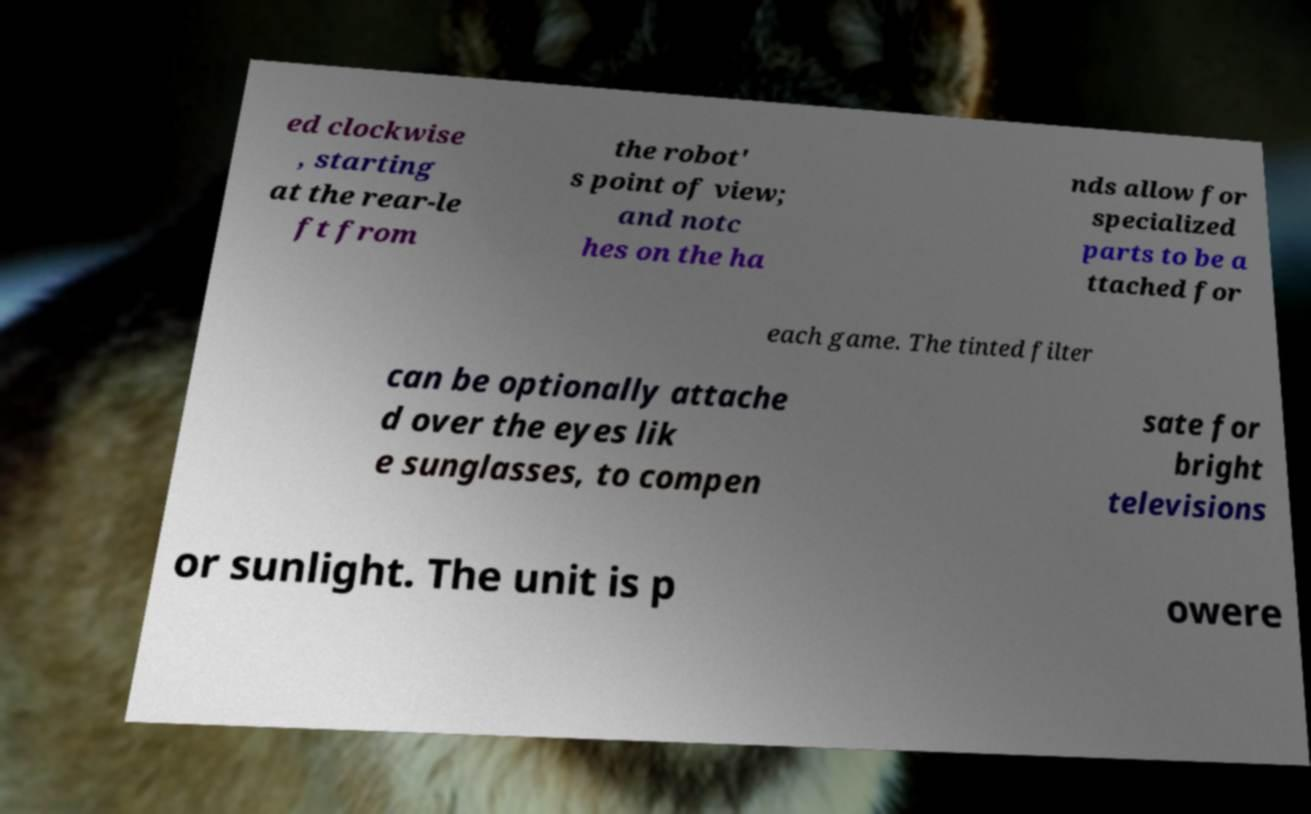Please read and relay the text visible in this image. What does it say? ed clockwise , starting at the rear-le ft from the robot' s point of view; and notc hes on the ha nds allow for specialized parts to be a ttached for each game. The tinted filter can be optionally attache d over the eyes lik e sunglasses, to compen sate for bright televisions or sunlight. The unit is p owere 